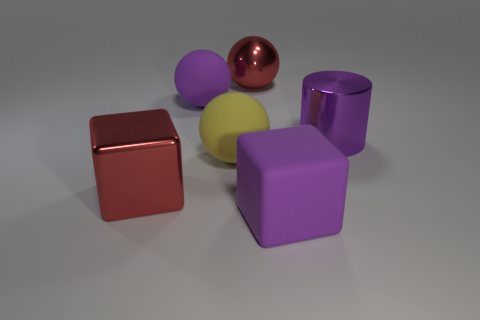The large metal cylinder is what color?
Keep it short and to the point. Purple. Does the matte object that is behind the yellow rubber thing have the same size as the thing on the right side of the large purple cube?
Your answer should be compact. Yes. Is the number of big purple objects less than the number of tiny red rubber things?
Provide a succinct answer. No. There is a red sphere; what number of big red spheres are behind it?
Provide a succinct answer. 0. What is the material of the cylinder?
Provide a short and direct response. Metal. Does the large cylinder have the same color as the large matte block?
Your answer should be compact. Yes. Is the number of large yellow rubber balls that are left of the large yellow matte object less than the number of big purple rubber cubes?
Provide a succinct answer. Yes. The big metal object to the left of the big purple rubber sphere is what color?
Keep it short and to the point. Red. The large yellow object has what shape?
Your answer should be compact. Sphere. There is a purple matte thing behind the metallic thing left of the big purple sphere; is there a large shiny block that is right of it?
Ensure brevity in your answer.  No. 